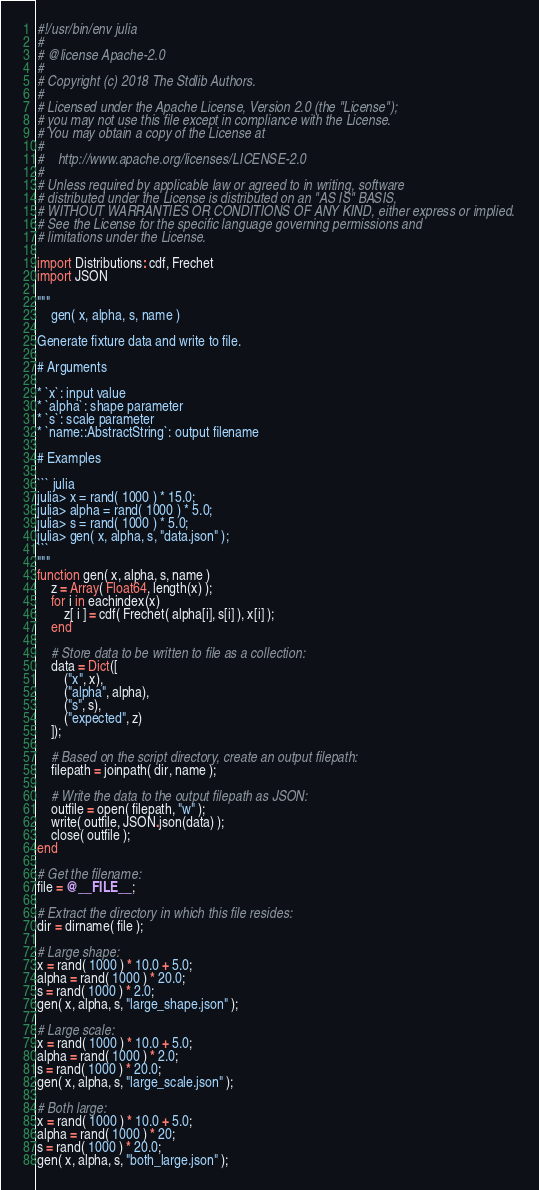<code> <loc_0><loc_0><loc_500><loc_500><_Julia_>#!/usr/bin/env julia
#
# @license Apache-2.0
#
# Copyright (c) 2018 The Stdlib Authors.
#
# Licensed under the Apache License, Version 2.0 (the "License");
# you may not use this file except in compliance with the License.
# You may obtain a copy of the License at
#
#    http://www.apache.org/licenses/LICENSE-2.0
#
# Unless required by applicable law or agreed to in writing, software
# distributed under the License is distributed on an "AS IS" BASIS,
# WITHOUT WARRANTIES OR CONDITIONS OF ANY KIND, either express or implied.
# See the License for the specific language governing permissions and
# limitations under the License.

import Distributions: cdf, Frechet
import JSON

"""
	gen( x, alpha, s, name )

Generate fixture data and write to file.

# Arguments

* `x`: input value
* `alpha`: shape parameter
* `s`: scale parameter
* `name::AbstractString`: output filename

# Examples

``` julia
julia> x = rand( 1000 ) * 15.0;
julia> alpha = rand( 1000 ) * 5.0;
julia> s = rand( 1000 ) * 5.0;
julia> gen( x, alpha, s, "data.json" );
```
"""
function gen( x, alpha, s, name )
	z = Array( Float64, length(x) );
	for i in eachindex(x)
		z[ i ] = cdf( Frechet( alpha[i], s[i] ), x[i] );
	end

	# Store data to be written to file as a collection:
	data = Dict([
		("x", x),
		("alpha", alpha),
		("s", s),
		("expected", z)
	]);

	# Based on the script directory, create an output filepath:
	filepath = joinpath( dir, name );

	# Write the data to the output filepath as JSON:
	outfile = open( filepath, "w" );
	write( outfile, JSON.json(data) );
	close( outfile );
end

# Get the filename:
file = @__FILE__;

# Extract the directory in which this file resides:
dir = dirname( file );

# Large shape:
x = rand( 1000 ) * 10.0 + 5.0;
alpha = rand( 1000 ) * 20.0;
s = rand( 1000 ) * 2.0;
gen( x, alpha, s, "large_shape.json" );

# Large scale:
x = rand( 1000 ) * 10.0 + 5.0;
alpha = rand( 1000 ) * 2.0;
s = rand( 1000 ) * 20.0;
gen( x, alpha, s, "large_scale.json" );

# Both large:
x = rand( 1000 ) * 10.0 + 5.0;
alpha = rand( 1000 ) * 20;
s = rand( 1000 ) * 20.0;
gen( x, alpha, s, "both_large.json" );
</code> 